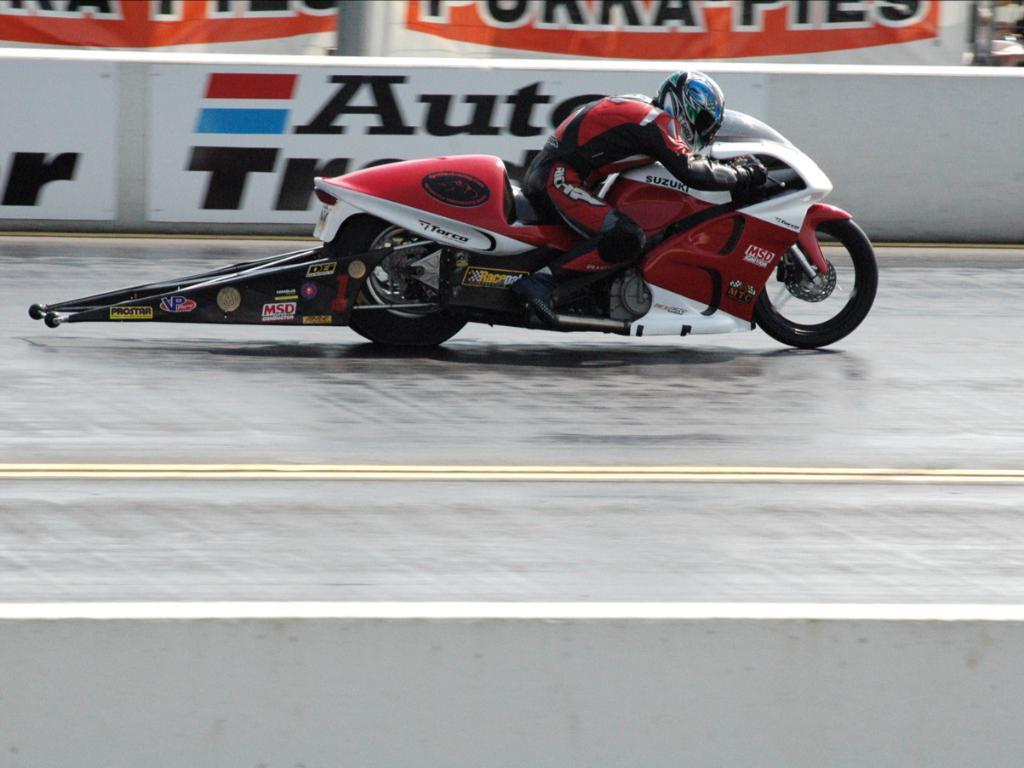What is the main subject of the image? There is a person in the image. What is the person wearing? The person is wearing clothes. What mode of transportation is the person using? The person is riding a two-wheeler. What can be seen in the background of the image? There is a road visible in the image, with white lines on it. What else is present in the image? There is a poster in the image, with text on it. Can you see a hen laying eggs in its nest in the image? There is no hen or nest present in the image. What type of feast is being prepared in the image? There is no feast or food preparation visible in the image. 